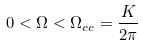<formula> <loc_0><loc_0><loc_500><loc_500>0 < \Omega < \Omega _ { c c } = \frac { K } { 2 \pi }</formula> 